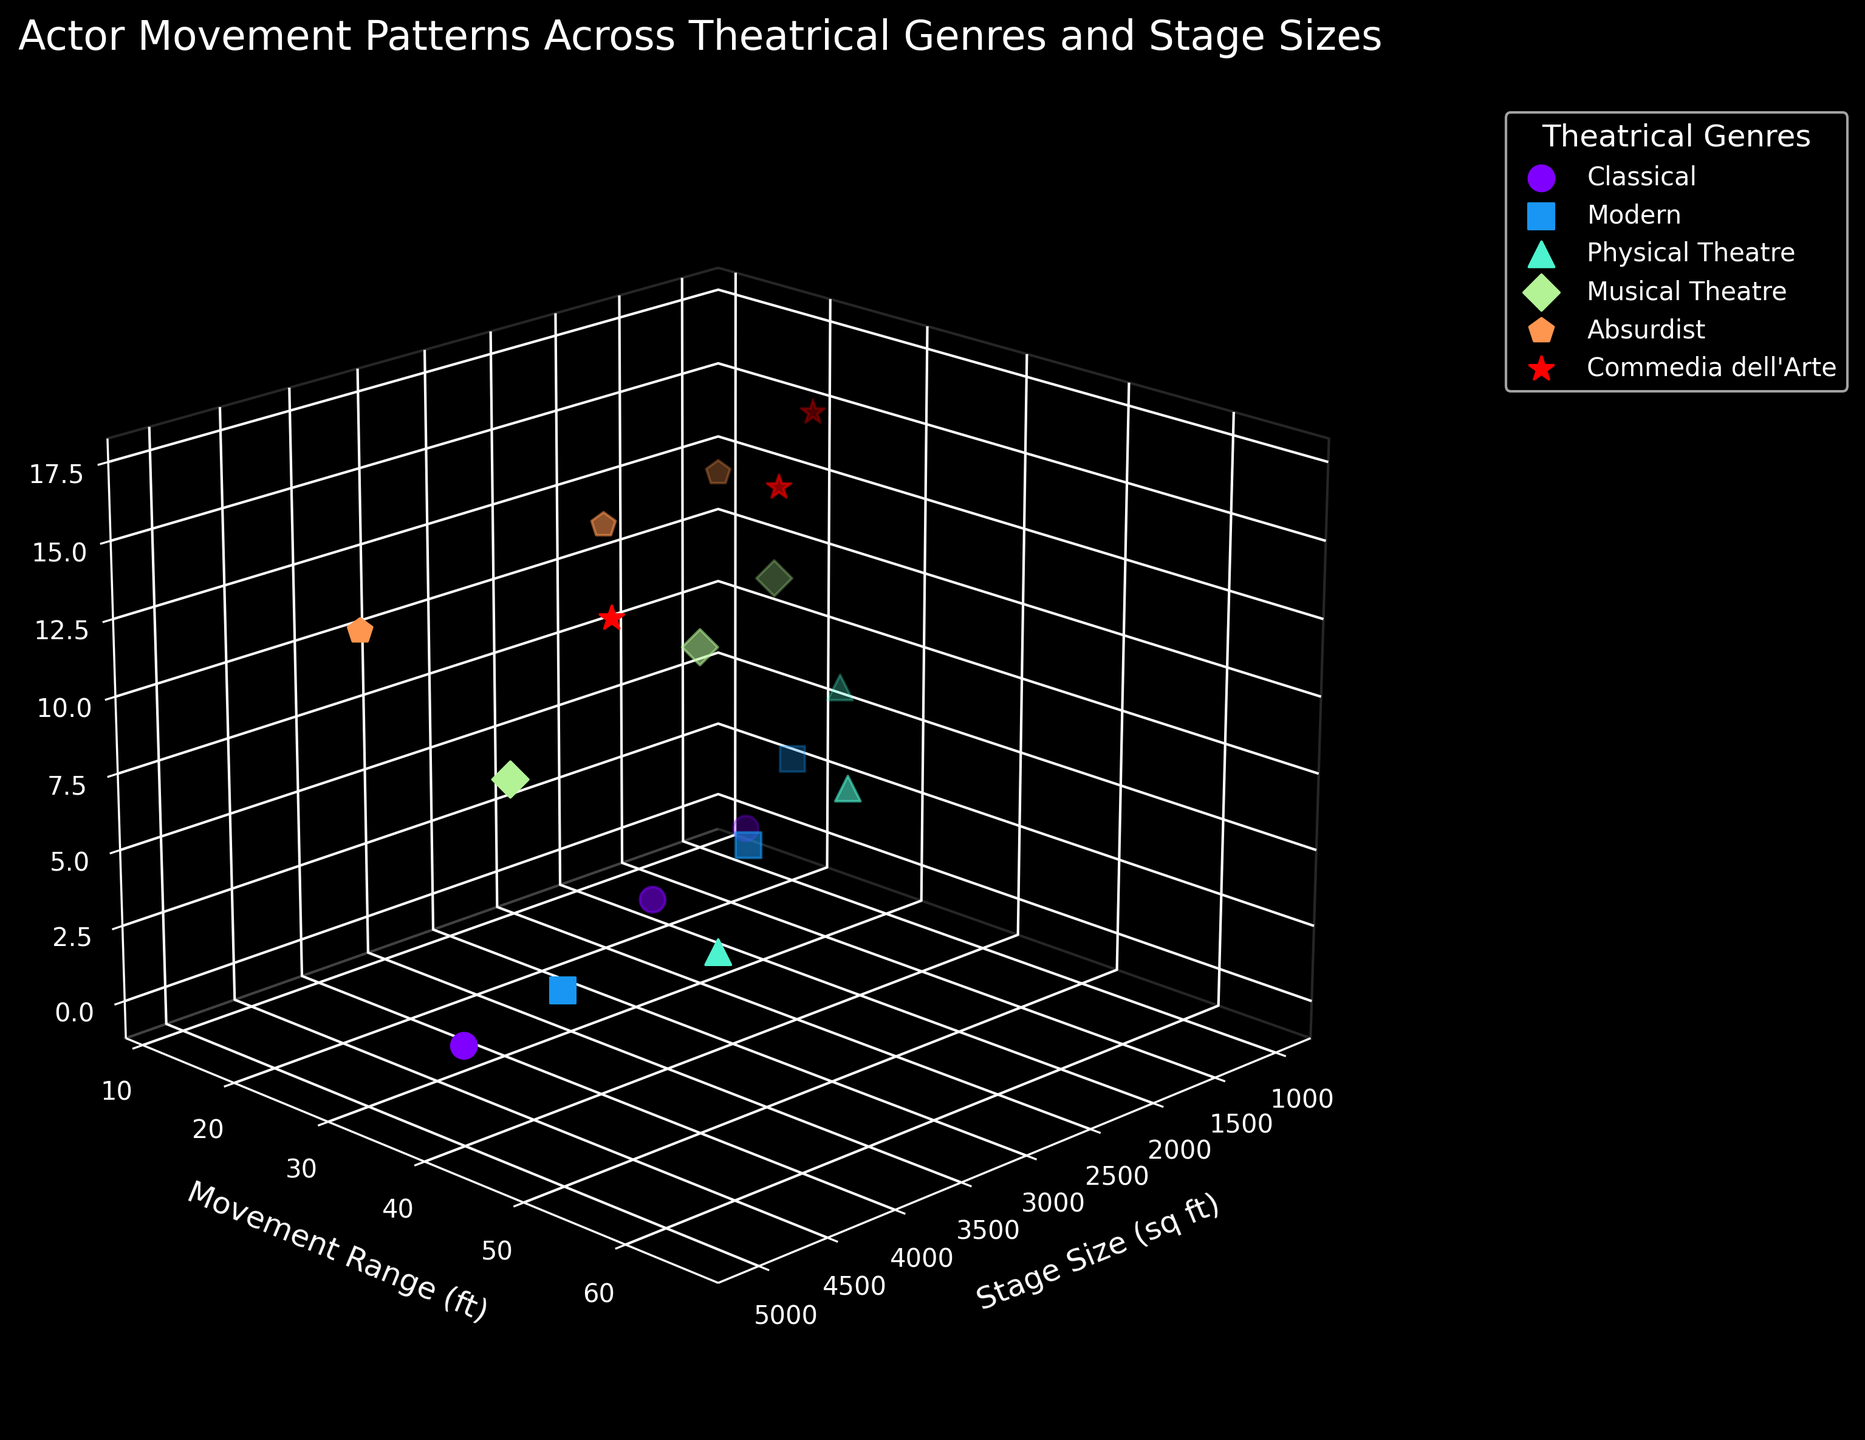What's the title of the plot? The title of the plot is usually located at the top. In this figure, it reads "Actor Movement Patterns Across Theatrical Genres and Stage Sizes."
Answer: Actor Movement Patterns Across Theatrical Genres and Stage Sizes What is represented on the x-axis of the plot? The x-axis label indicates that it represents the stage size in square feet (sq ft).
Answer: Stage size (sq ft) Which aspect of the actors' movements is shown on the y-axis? The y-axis label denotes that it shows the movement range in feet (ft).
Answer: Movement range (ft) What does the color code in the plot represent? The legend indicates that each color corresponds to a different theatrical genre.
Answer: Theatrical genres Which genre had the highest movement range on a 5000 sq ft stage? Upon examining the points where Stage Size is 5000 sq ft, Physical Theatre has the highest Movement Range at 65 ft.
Answer: Physical Theatre Comparing Classical and Modern genres, which one generally exhibits a larger movement range for the same stage size? By comparing the same stage sizes, Modern generally shows larger movement ranges: 20 ft vs. 15 ft at 1000 sq ft, 35 ft vs. 25 ft at 2500 sq ft, and 50 ft vs. 40 ft at 5000 sq ft.
Answer: Modern How many unique theatrical genres are shown in the plot? The legend lists the unique genres, which are Classical, Modern, Physical Theatre, Musical Theatre, Absurdist, and Commedia dell'Arte. There are six unique genres.
Answer: Six Which genre has the smallest movement range (in ft) on the smallest stage size (1000 sq ft)? Looking at the points where Stage Size is 1000 sq ft, Absurdist has the smallest Movement Range at 12 ft.
Answer: Absurdist What theme does the plot use for its visual style? The overall dark hues and grid suggest that the plot is using a dark background style.
Answer: Dark background How does the movement range change for Musical Theatre as the stage size increases from 1000 to 5000 sq ft? The data shows that for Musical Theatre, the movement range increases from 18 ft at 1000 sq ft, to 30 ft at 2500 sq ft, and 45 ft at 5000 sq ft.
Answer: Increases 